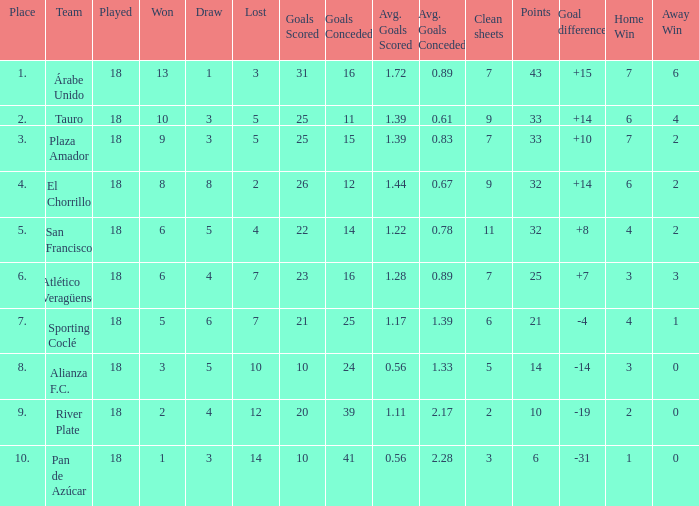How many points did the team have that conceded 41 goals and finish in a place larger than 10? 0.0. 